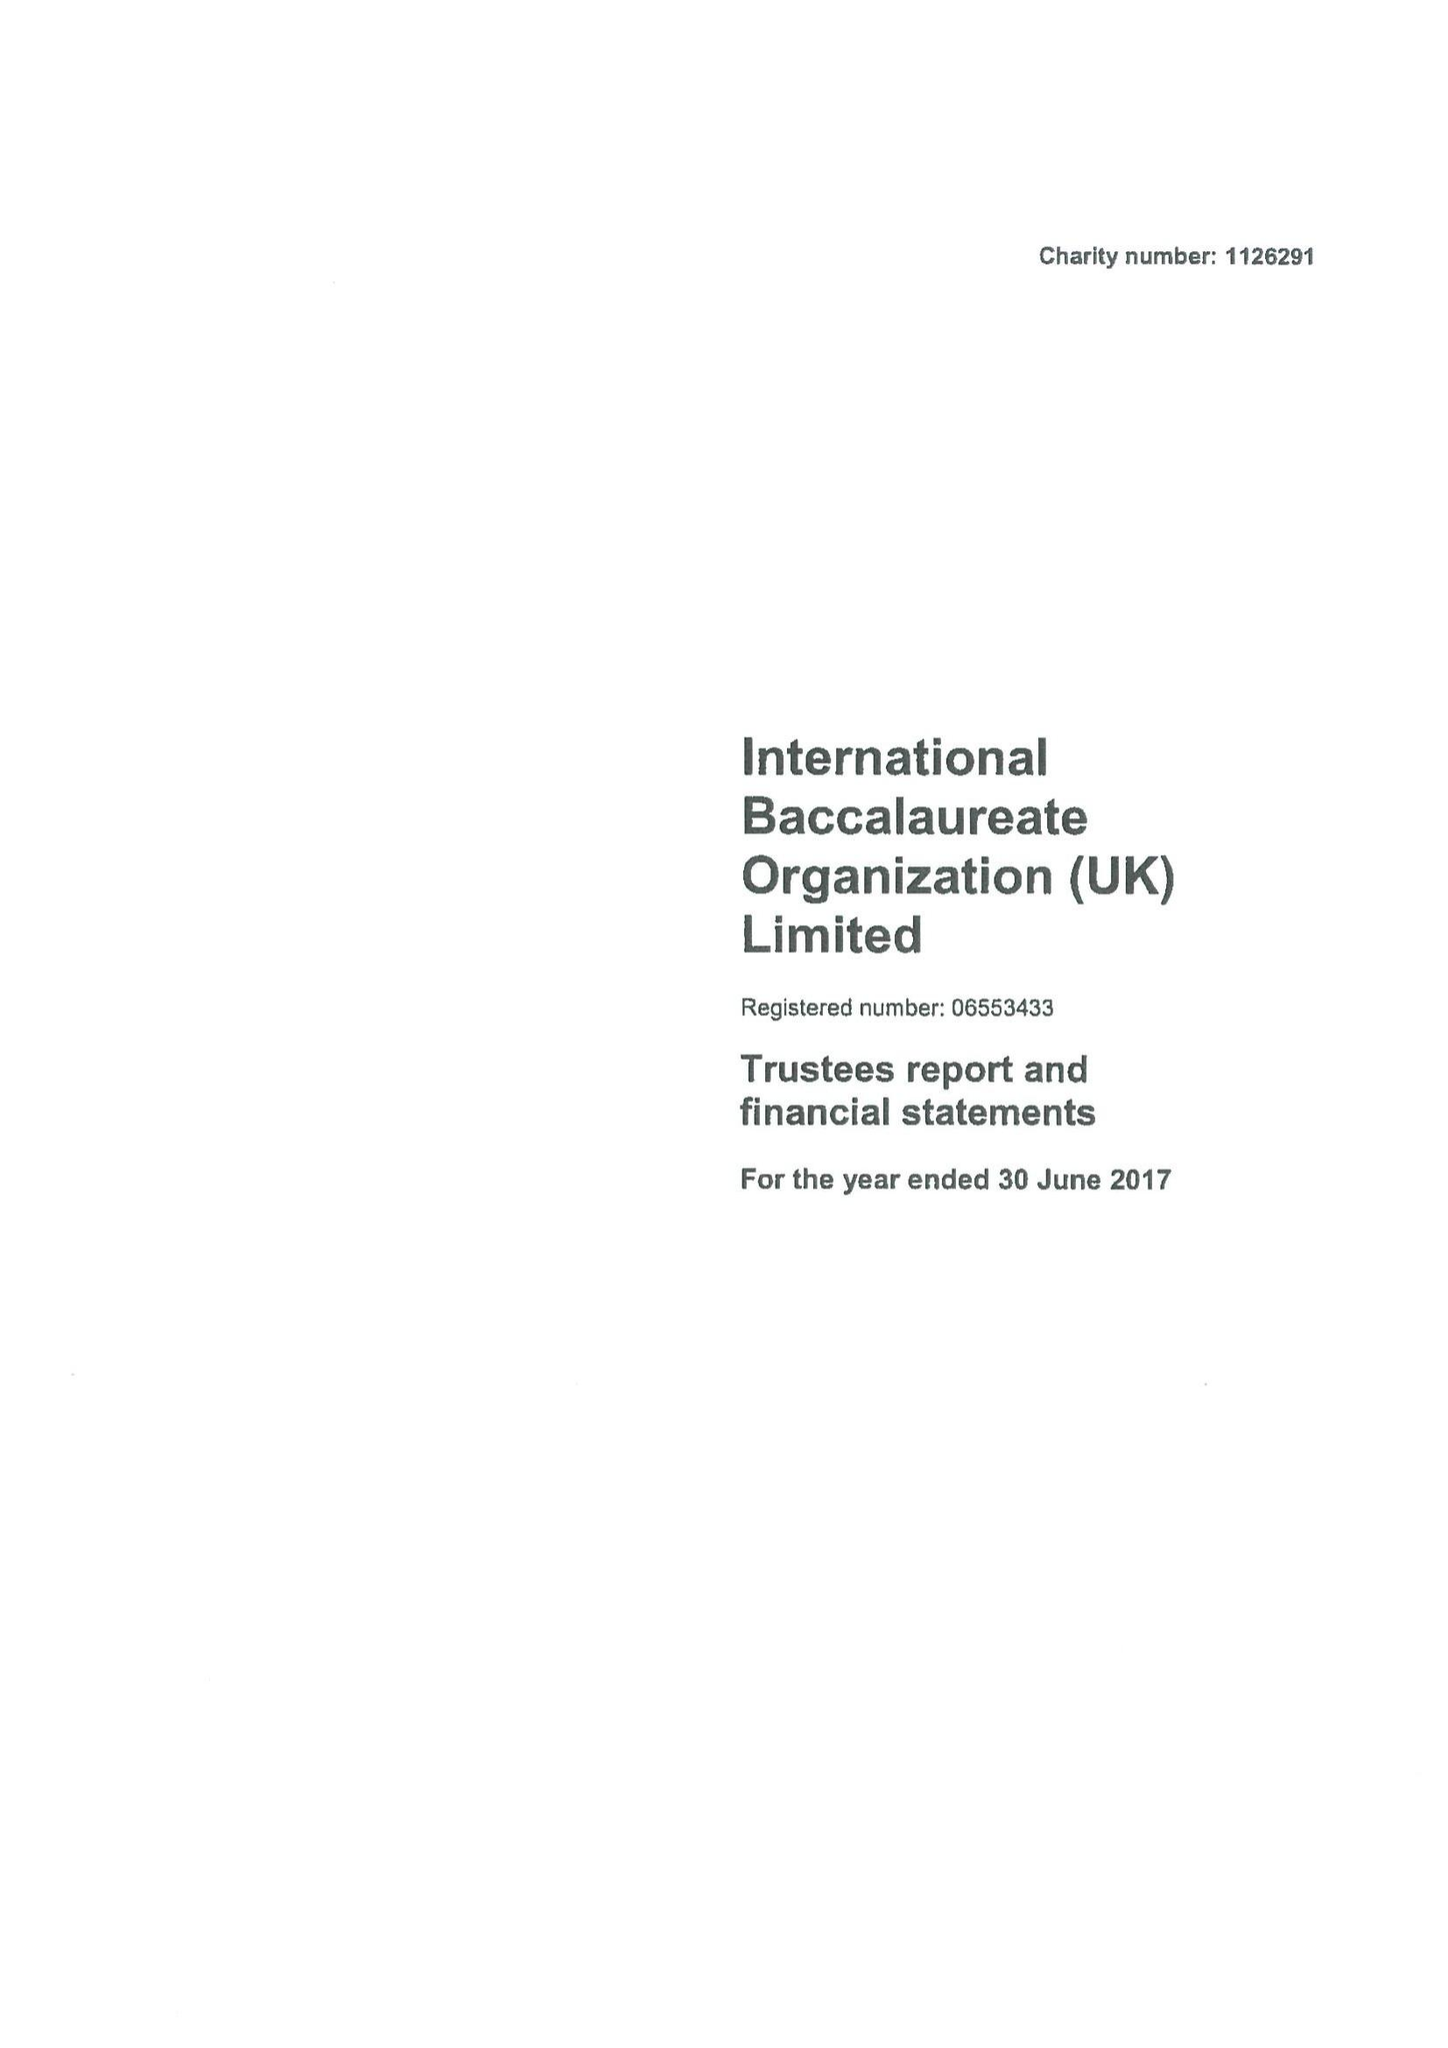What is the value for the address__post_town?
Answer the question using a single word or phrase. None 